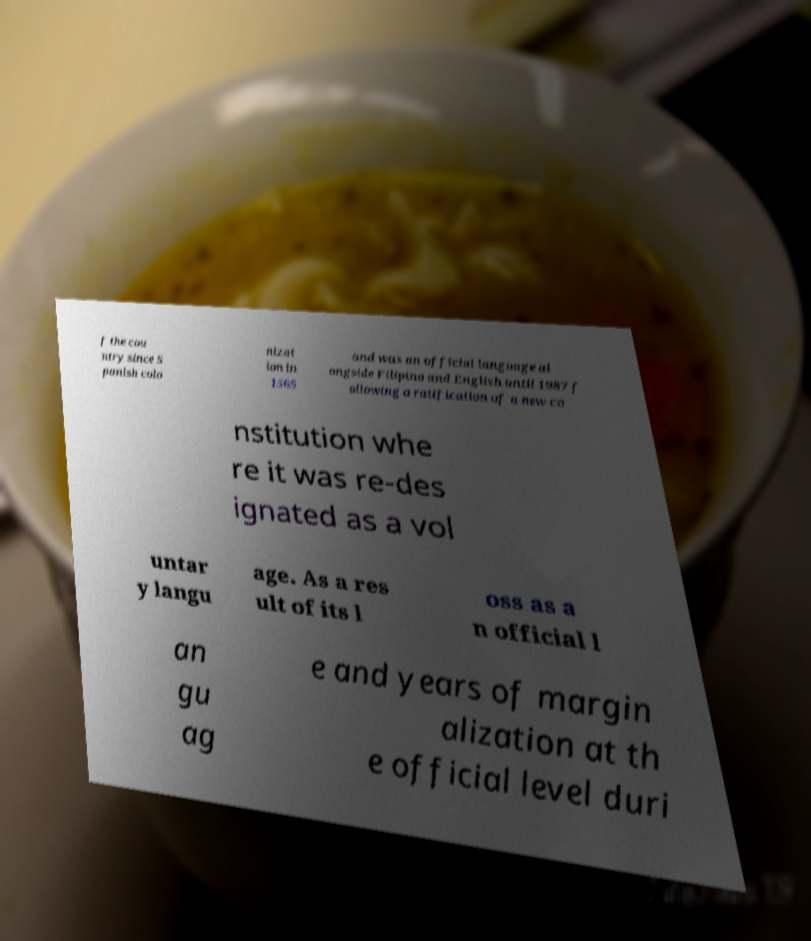What messages or text are displayed in this image? I need them in a readable, typed format. f the cou ntry since S panish colo nizat ion in 1565 and was an official language al ongside Filipino and English until 1987 f ollowing a ratification of a new co nstitution whe re it was re-des ignated as a vol untar y langu age. As a res ult of its l oss as a n official l an gu ag e and years of margin alization at th e official level duri 